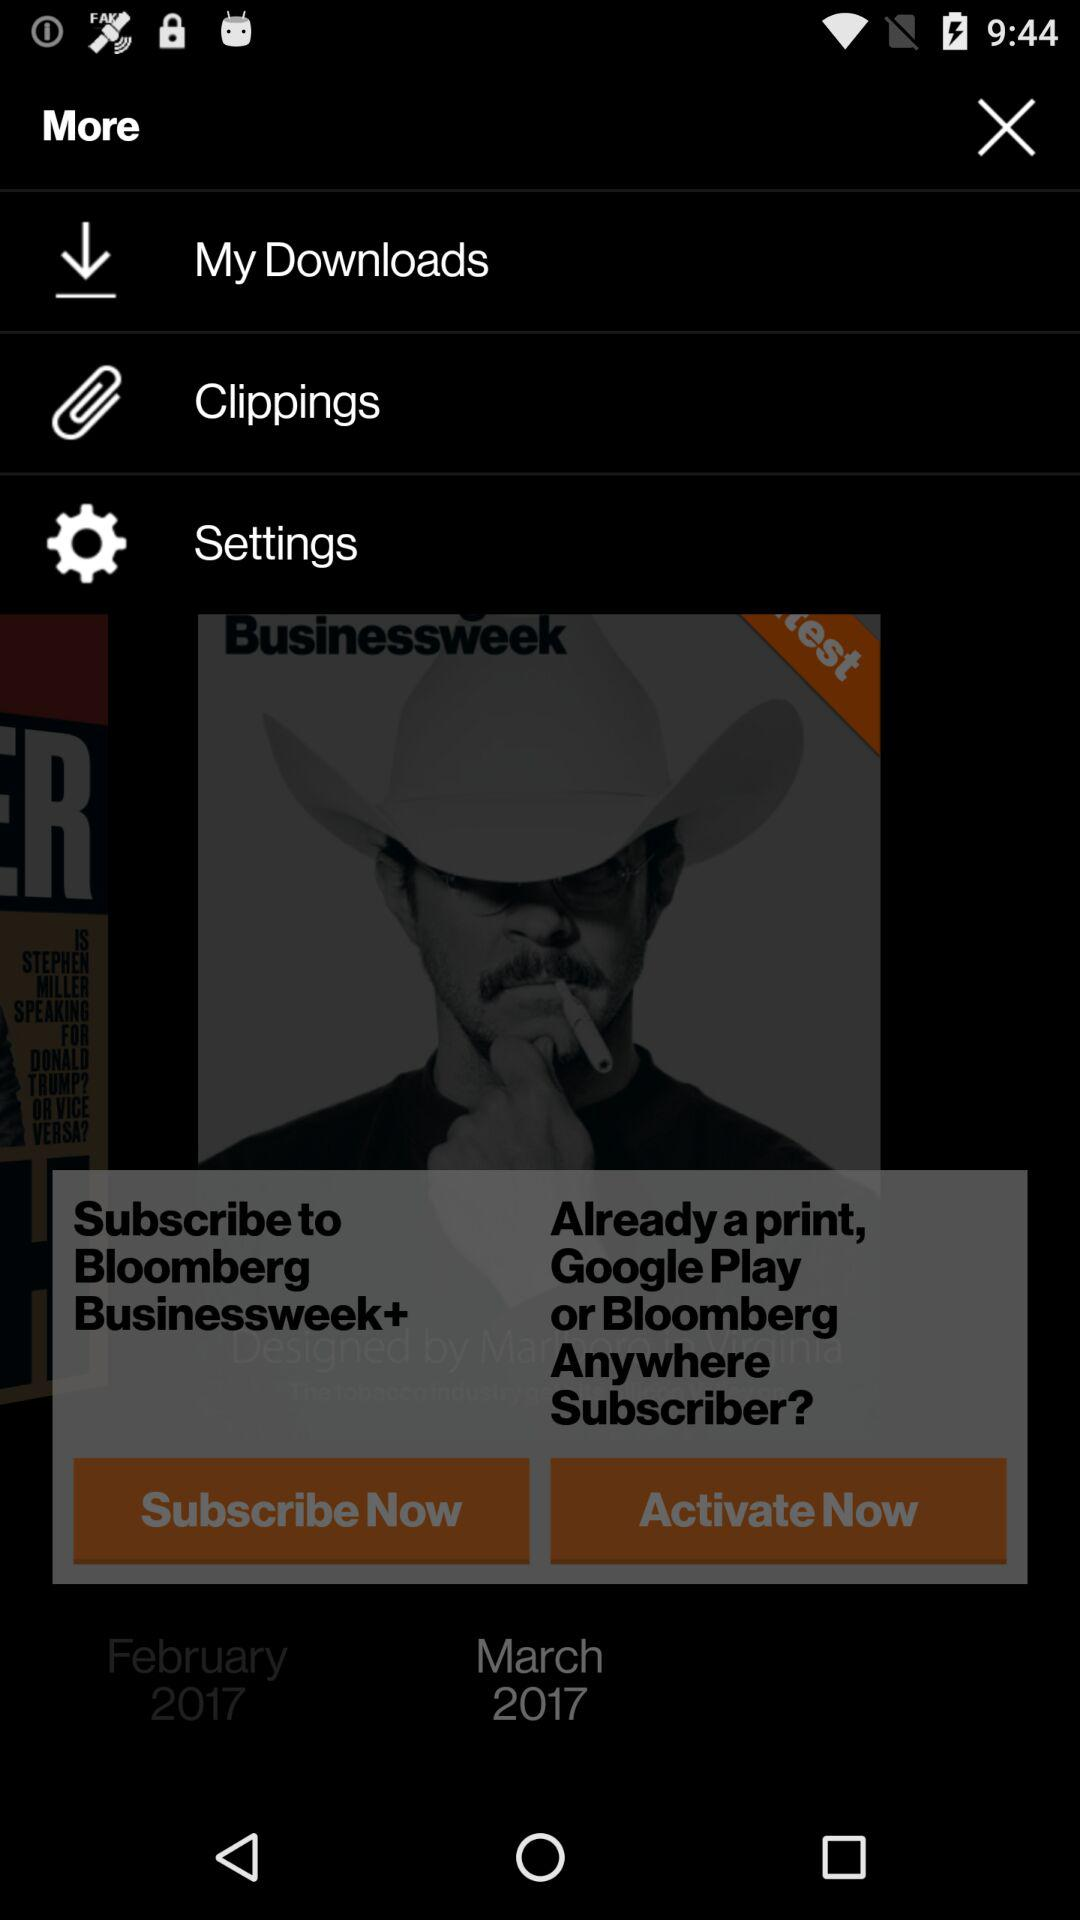How many months are displayed on the page?
Answer the question using a single word or phrase. 2 